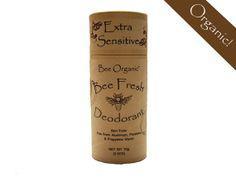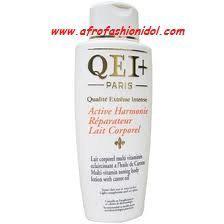The first image is the image on the left, the second image is the image on the right. Evaluate the accuracy of this statement regarding the images: "Left image shows a product with orange top half and light bottom half.". Is it true? Answer yes or no. No. The first image is the image on the left, the second image is the image on the right. Analyze the images presented: Is the assertion "In one image, a product in a tube stands on end beside the box in which it is packaged to be sold." valid? Answer yes or no. No. 